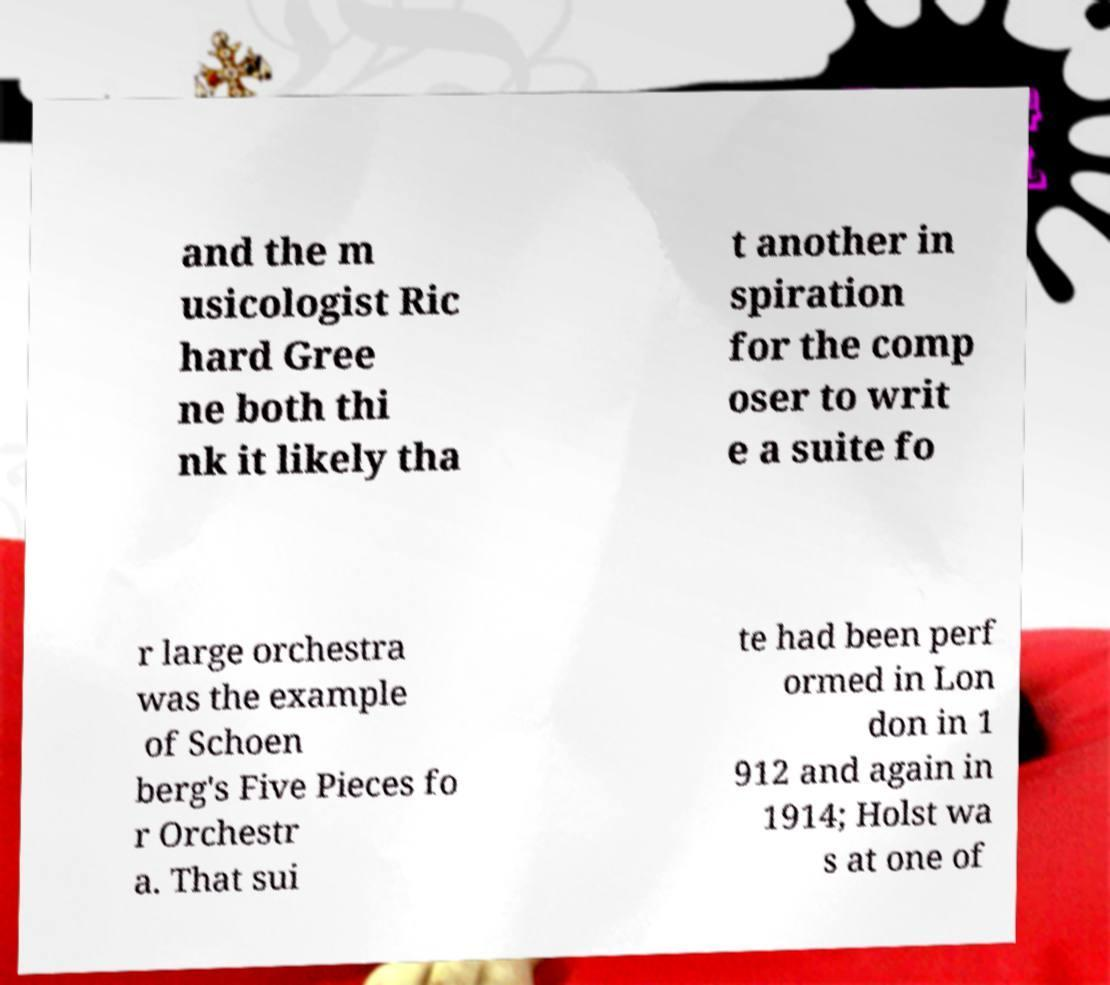Please read and relay the text visible in this image. What does it say? and the m usicologist Ric hard Gree ne both thi nk it likely tha t another in spiration for the comp oser to writ e a suite fo r large orchestra was the example of Schoen berg's Five Pieces fo r Orchestr a. That sui te had been perf ormed in Lon don in 1 912 and again in 1914; Holst wa s at one of 